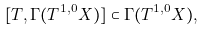Convert formula to latex. <formula><loc_0><loc_0><loc_500><loc_500>[ T , \Gamma ( T ^ { 1 , 0 } X ) ] \subset \Gamma ( T ^ { 1 , 0 } X ) ,</formula> 